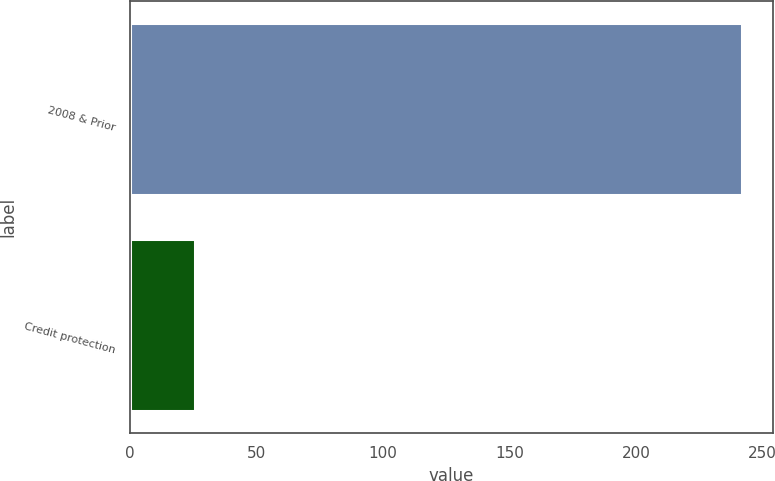<chart> <loc_0><loc_0><loc_500><loc_500><bar_chart><fcel>2008 & Prior<fcel>Credit protection<nl><fcel>242<fcel>25.8<nl></chart> 